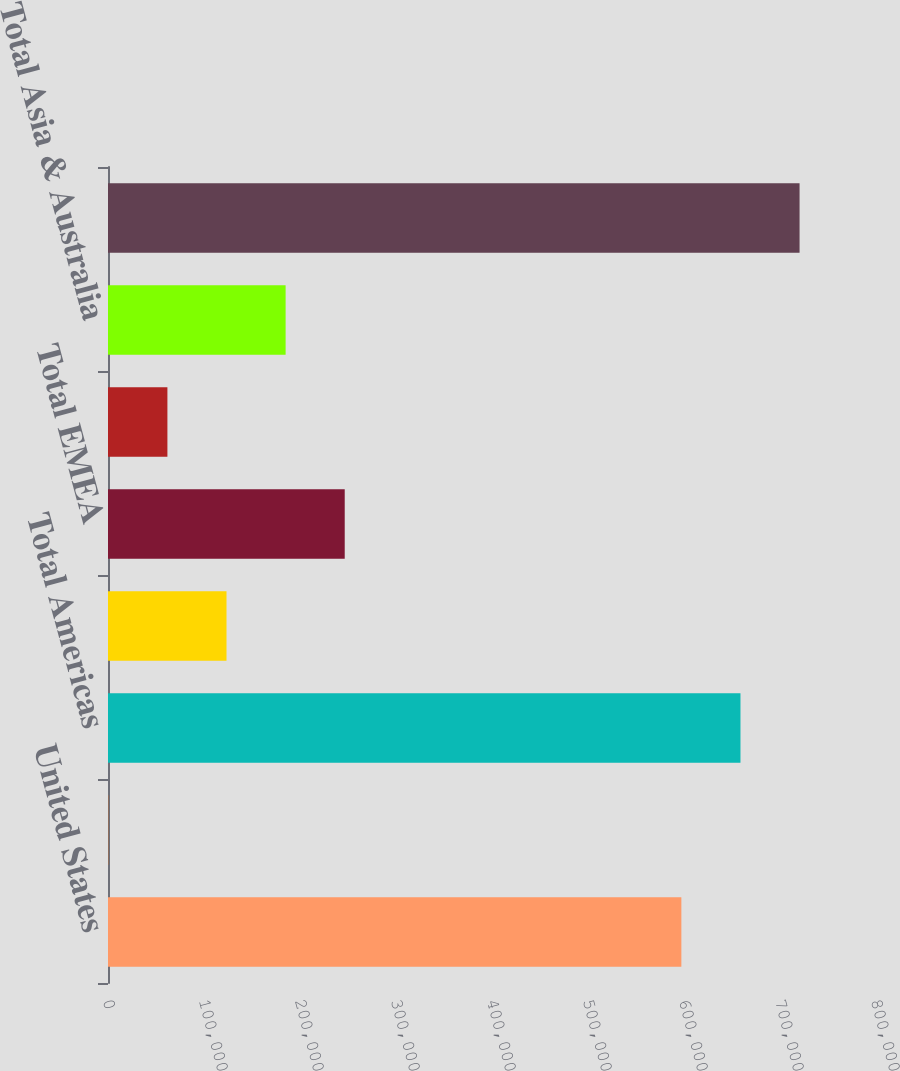<chart> <loc_0><loc_0><loc_500><loc_500><bar_chart><fcel>United States<fcel>Other<fcel>Total Americas<fcel>United Kingdom<fcel>Total EMEA<fcel>Japan<fcel>Total Asia & Australia<fcel>Total<nl><fcel>597254<fcel>320<fcel>658820<fcel>123451<fcel>246583<fcel>61885.7<fcel>185017<fcel>720385<nl></chart> 